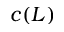<formula> <loc_0><loc_0><loc_500><loc_500>c ( L )</formula> 